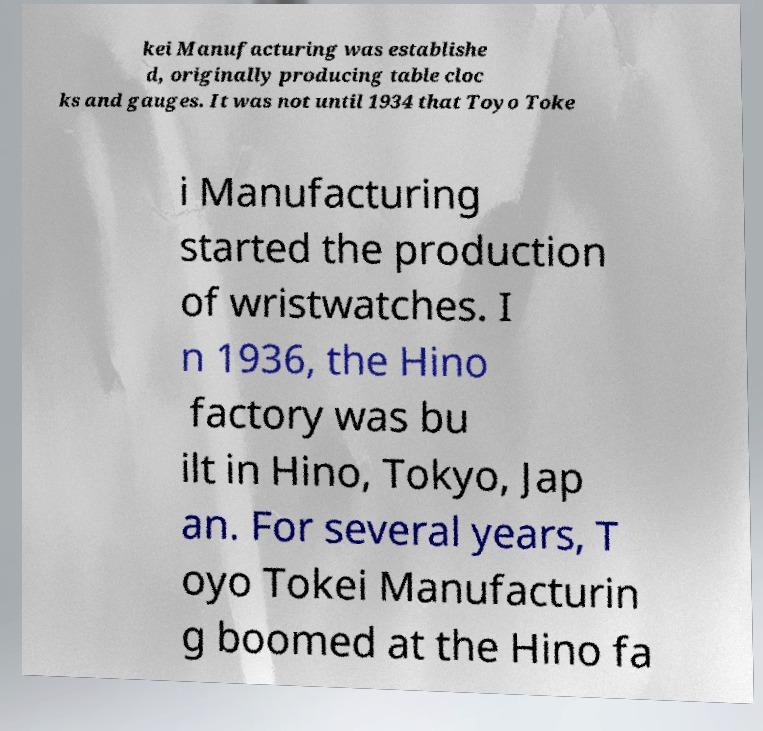Can you accurately transcribe the text from the provided image for me? kei Manufacturing was establishe d, originally producing table cloc ks and gauges. It was not until 1934 that Toyo Toke i Manufacturing started the production of wristwatches. I n 1936, the Hino factory was bu ilt in Hino, Tokyo, Jap an. For several years, T oyo Tokei Manufacturin g boomed at the Hino fa 